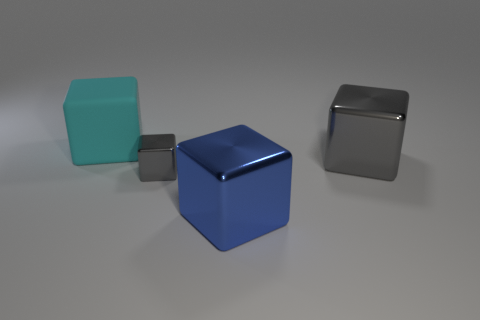What number of other matte objects are the same shape as the tiny gray thing?
Your response must be concise. 1. How many cyan objects are small blocks or rubber cubes?
Provide a succinct answer. 1. What size is the gray metallic thing that is left of the cube on the right side of the blue cube?
Provide a short and direct response. Small. What material is the other tiny object that is the same shape as the blue thing?
Provide a succinct answer. Metal. What number of other cyan objects have the same size as the cyan object?
Offer a very short reply. 0. Does the cyan thing have the same size as the blue metallic cube?
Make the answer very short. Yes. How big is the metal cube that is behind the blue shiny block and on the left side of the large gray block?
Offer a terse response. Small. Are there more cyan rubber objects that are in front of the blue metal thing than big shiny cubes in front of the small object?
Provide a succinct answer. No. The small thing that is the same shape as the big blue thing is what color?
Offer a very short reply. Gray. There is a metallic thing that is right of the blue metal object; is its color the same as the rubber object?
Give a very brief answer. No. 